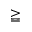Convert formula to latex. <formula><loc_0><loc_0><loc_500><loc_500>\geqq</formula> 